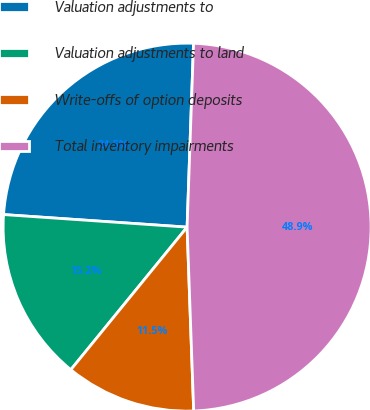Convert chart to OTSL. <chart><loc_0><loc_0><loc_500><loc_500><pie_chart><fcel>Valuation adjustments to<fcel>Valuation adjustments to land<fcel>Write-offs of option deposits<fcel>Total inventory impairments<nl><fcel>24.47%<fcel>15.2%<fcel>11.46%<fcel>48.87%<nl></chart> 